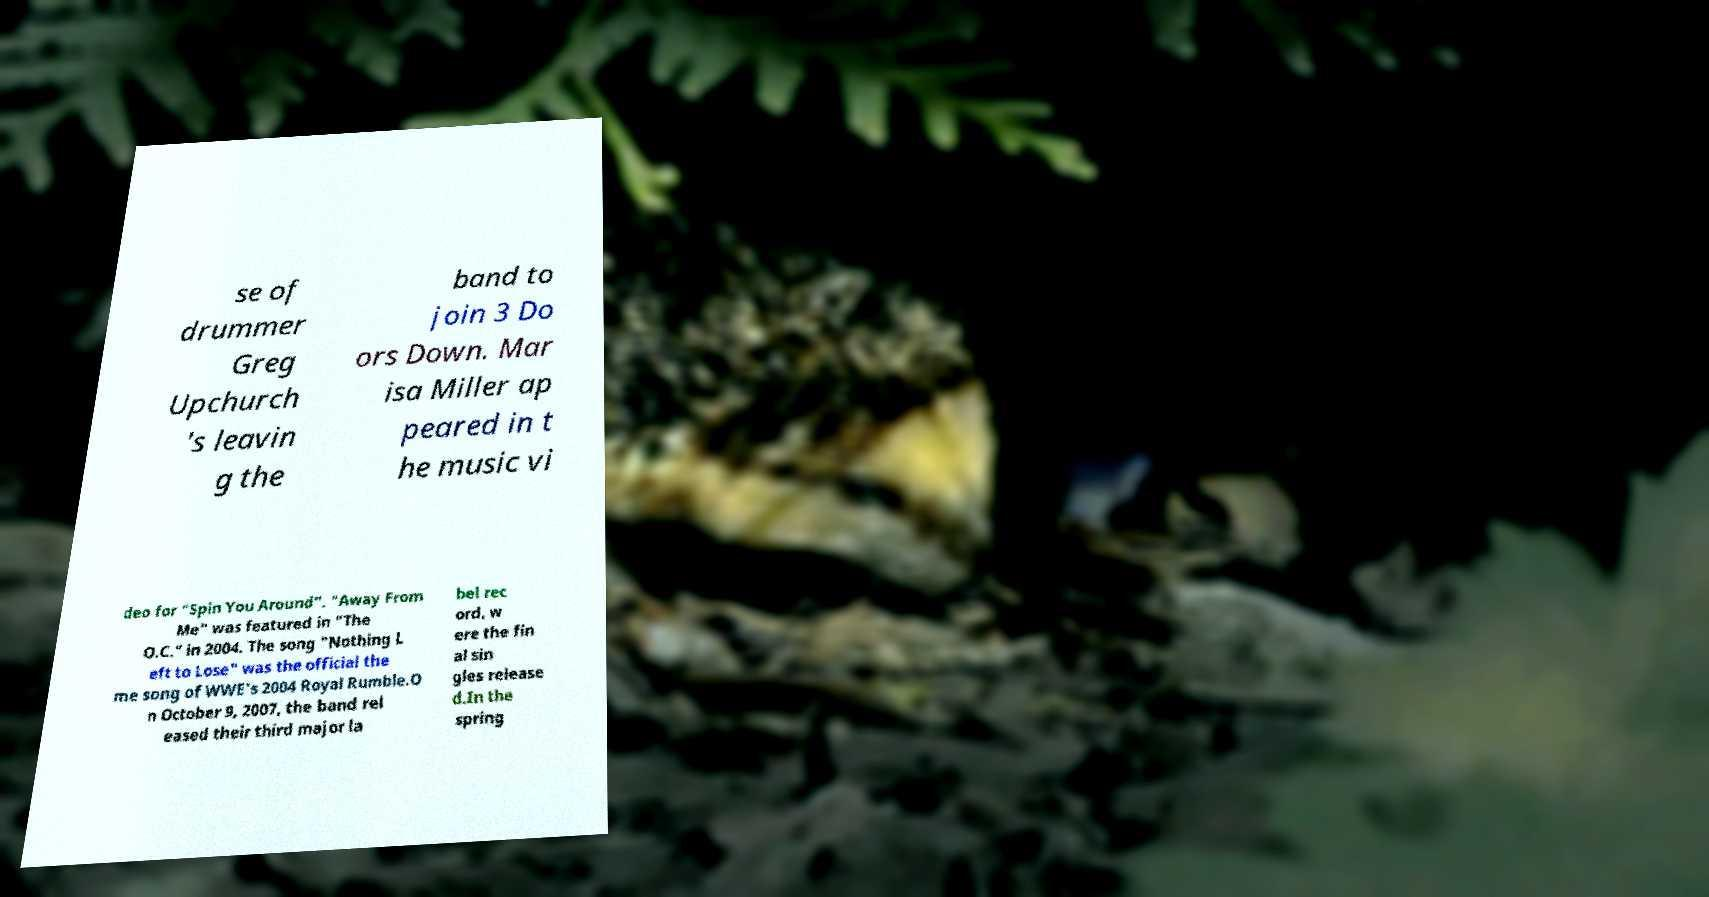What messages or text are displayed in this image? I need them in a readable, typed format. se of drummer Greg Upchurch 's leavin g the band to join 3 Do ors Down. Mar isa Miller ap peared in t he music vi deo for "Spin You Around". "Away From Me" was featured in "The O.C." in 2004. The song "Nothing L eft to Lose" was the official the me song of WWE's 2004 Royal Rumble.O n October 9, 2007, the band rel eased their third major la bel rec ord, w ere the fin al sin gles release d.In the spring 